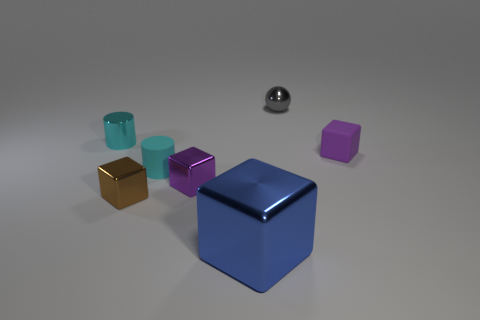Subtract all purple metallic blocks. How many blocks are left? 3 Subtract all cylinders. How many objects are left? 5 Add 2 tiny purple rubber objects. How many objects exist? 9 Subtract all purple cubes. How many cubes are left? 2 Subtract 1 blue blocks. How many objects are left? 6 Subtract 1 cubes. How many cubes are left? 3 Subtract all purple blocks. Subtract all cyan spheres. How many blocks are left? 2 Subtract all blue balls. How many purple blocks are left? 2 Subtract all tiny blue shiny cylinders. Subtract all small cyan matte things. How many objects are left? 6 Add 3 tiny cyan matte cylinders. How many tiny cyan matte cylinders are left? 4 